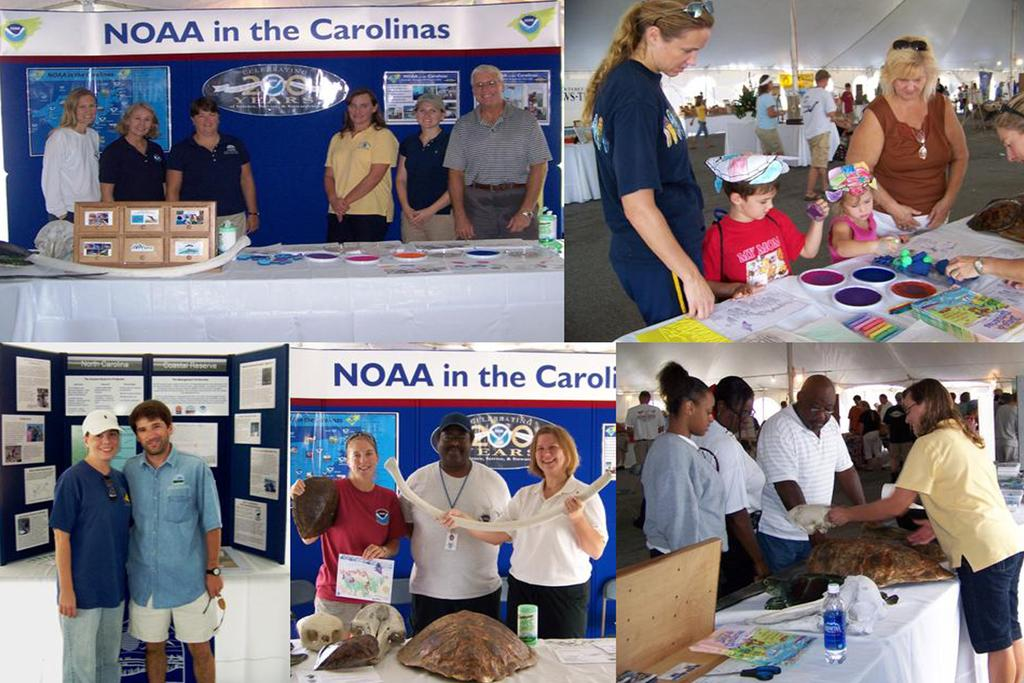What is the main subject of the collage image? The main subject of the collage image is people. What else can be seen in the collage image besides people? There are objects on tables and banners in the collage image. How many ladybugs are present in the collage image? There are no ladybugs present in the collage image. What type of bait is being used in the collage image? There is no bait present in the collage image. 